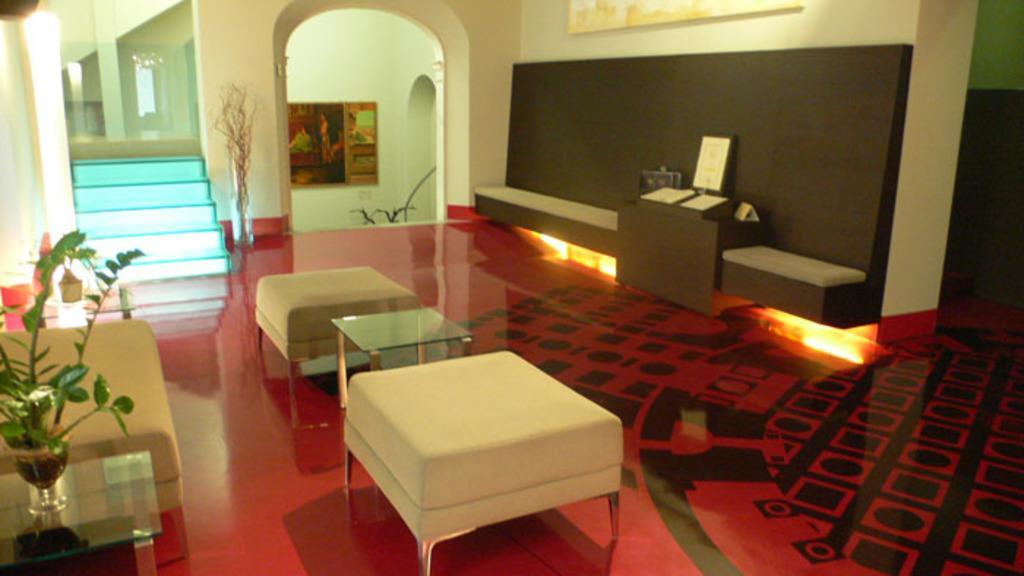Describe this image in one or two sentences. This image is taken in a living room. We can see stairs and a flower plant on the coffee table and we can also see a sofa, a frame and a painting attached to the wall. At the bottom there is floor. 